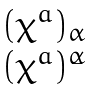<formula> <loc_0><loc_0><loc_500><loc_500>\begin{matrix} ( \chi ^ { a } ) _ { \alpha } \\ ( \bar { \chi } ^ { a } ) ^ { \dot { \alpha } } \end{matrix}</formula> 